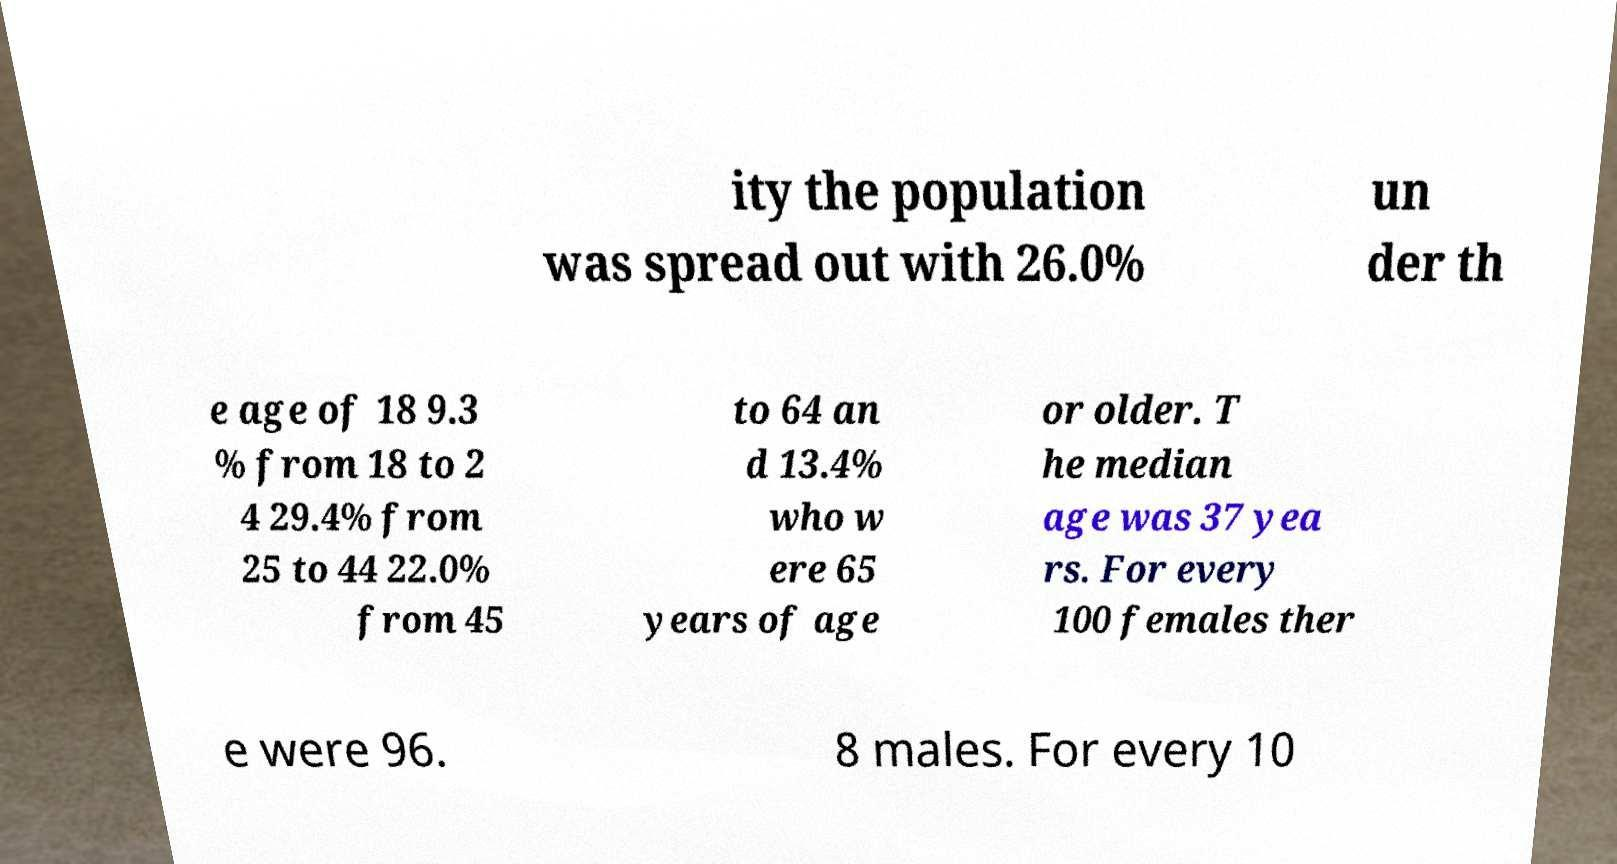I need the written content from this picture converted into text. Can you do that? ity the population was spread out with 26.0% un der th e age of 18 9.3 % from 18 to 2 4 29.4% from 25 to 44 22.0% from 45 to 64 an d 13.4% who w ere 65 years of age or older. T he median age was 37 yea rs. For every 100 females ther e were 96. 8 males. For every 10 